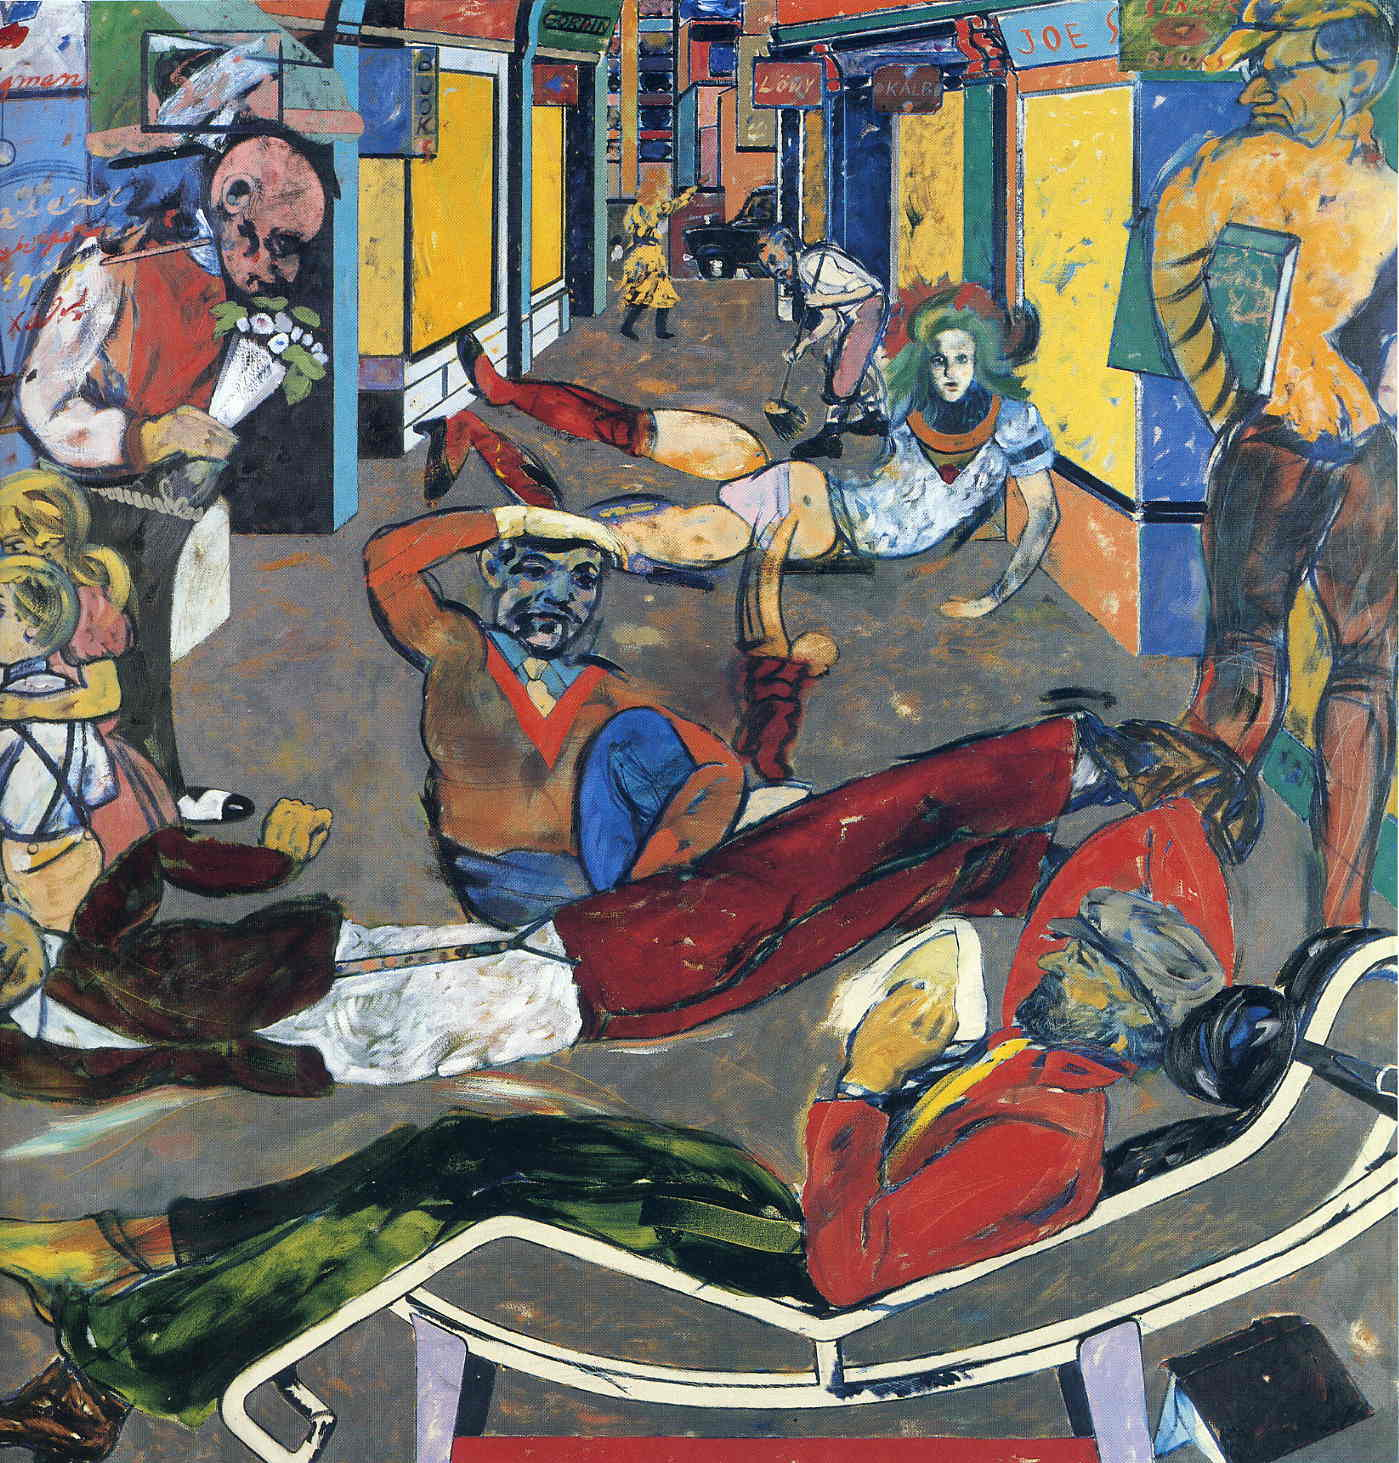What's happening in the scene? The image presents a vibrant street scene that exudes energy and movement, captured in a distinctive expressionist art style. Various characters populate the scene, each engaged in a unique activity, from dancing and playing musical instruments to reading and casual promenading. The figures exhibit exaggerated and distorted features typical of expressionist art, aiming to evoke more emotion and subjective interpretation rather than realistic depiction.

The use of bold and varied colors enhances the dynamism and chaotic ambiance of the scene. In the background, an array of buildings and signposts hint at a bustling urban environment, contributing to the overall sense of lively commotion. This composition, characterized by its vibrant hues and dynamic brushwork, aligns with post-impressionist tendencies, where emotional resonance and experimental techniques take precedence over realistic representation. 